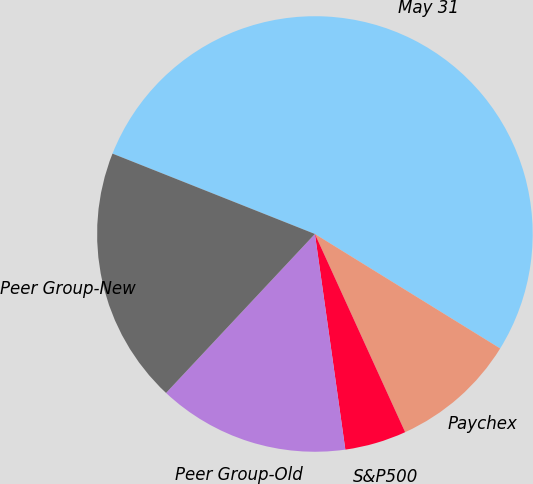Convert chart. <chart><loc_0><loc_0><loc_500><loc_500><pie_chart><fcel>May 31<fcel>Paychex<fcel>S&P500<fcel>Peer Group-Old<fcel>Peer Group-New<nl><fcel>52.8%<fcel>9.39%<fcel>4.57%<fcel>14.21%<fcel>19.04%<nl></chart> 